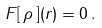Convert formula to latex. <formula><loc_0><loc_0><loc_500><loc_500>F [ \, \rho \, ] ( { r } ) = 0 \, .</formula> 